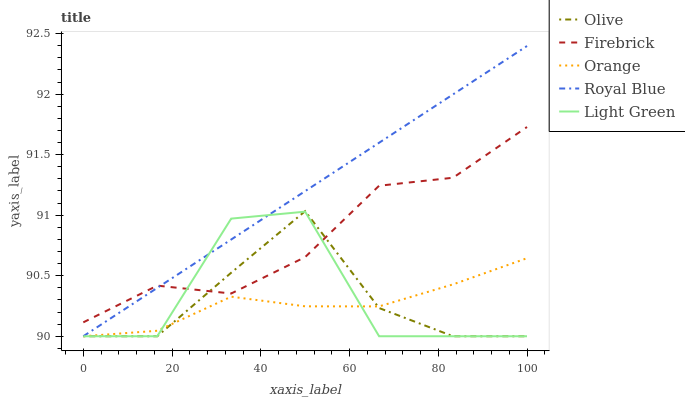Does Orange have the minimum area under the curve?
Answer yes or no. Yes. Does Royal Blue have the maximum area under the curve?
Answer yes or no. Yes. Does Firebrick have the minimum area under the curve?
Answer yes or no. No. Does Firebrick have the maximum area under the curve?
Answer yes or no. No. Is Royal Blue the smoothest?
Answer yes or no. Yes. Is Light Green the roughest?
Answer yes or no. Yes. Is Orange the smoothest?
Answer yes or no. No. Is Orange the roughest?
Answer yes or no. No. Does Firebrick have the lowest value?
Answer yes or no. No. Does Royal Blue have the highest value?
Answer yes or no. Yes. Does Firebrick have the highest value?
Answer yes or no. No. Is Orange less than Firebrick?
Answer yes or no. Yes. Is Firebrick greater than Orange?
Answer yes or no. Yes. Does Orange intersect Firebrick?
Answer yes or no. No. 